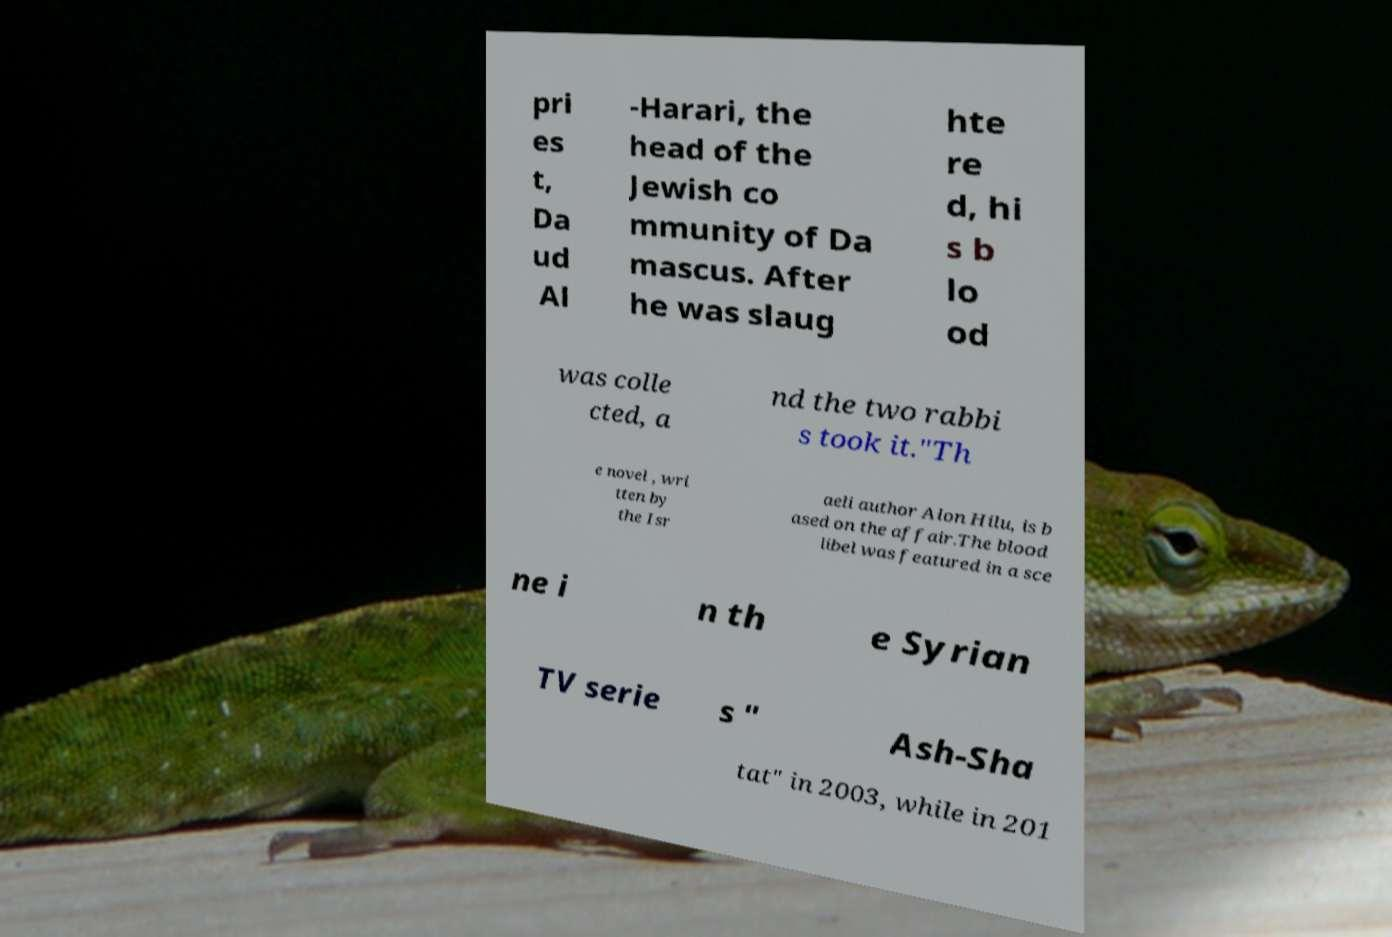Can you accurately transcribe the text from the provided image for me? pri es t, Da ud Al -Harari, the head of the Jewish co mmunity of Da mascus. After he was slaug hte re d, hi s b lo od was colle cted, a nd the two rabbi s took it."Th e novel , wri tten by the Isr aeli author Alon Hilu, is b ased on the affair.The blood libel was featured in a sce ne i n th e Syrian TV serie s " Ash-Sha tat" in 2003, while in 201 